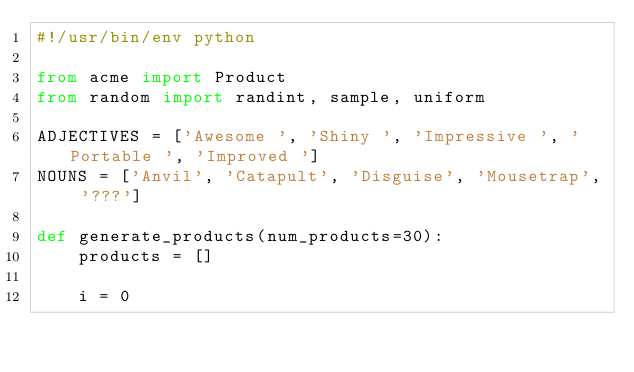Convert code to text. <code><loc_0><loc_0><loc_500><loc_500><_Python_>#!/usr/bin/env python

from acme import Product
from random import randint, sample, uniform

ADJECTIVES = ['Awesome ', 'Shiny ', 'Impressive ', 'Portable ', 'Improved ']
NOUNS = ['Anvil', 'Catapult', 'Disguise', 'Mousetrap', '???']

def generate_products(num_products=30):
    products = []

    i = 0</code> 